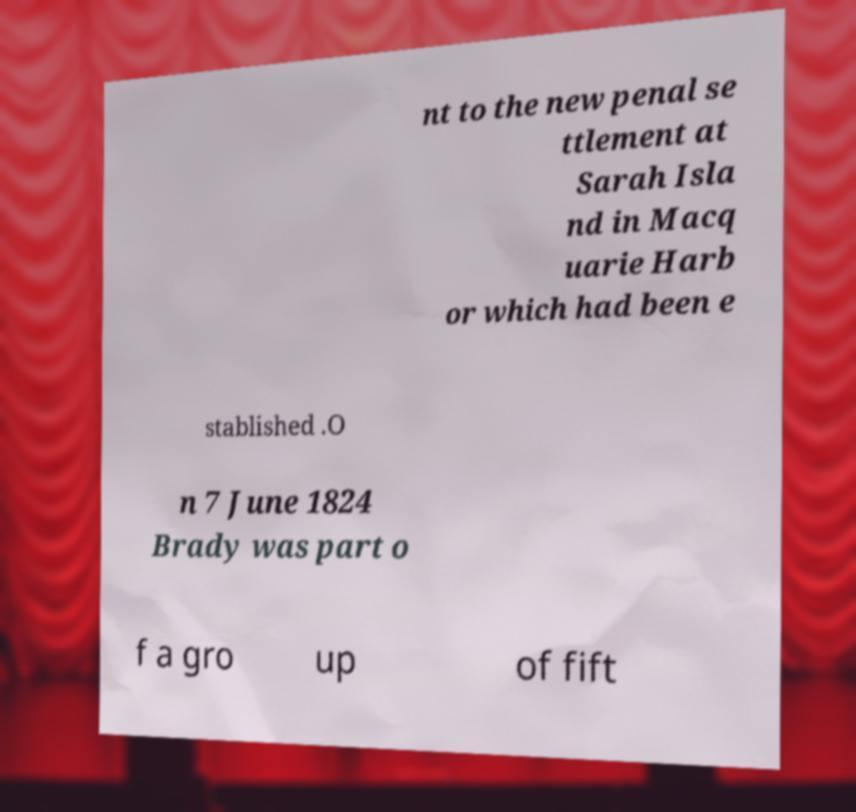Please read and relay the text visible in this image. What does it say? nt to the new penal se ttlement at Sarah Isla nd in Macq uarie Harb or which had been e stablished .O n 7 June 1824 Brady was part o f a gro up of fift 